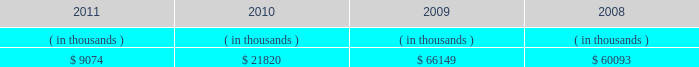Entergy new orleans , inc .
Management 2019s financial discussion and analysis also in addition to the contractual obligations , entergy new orleans has $ 53.7 million of unrecognized tax benefits and interest net of unused tax attributes and payments for which the timing of payments beyond 12 months cannot be reasonably estimated due to uncertainties in the timing of effective settlement of tax positions .
See note 3 to the financial statements for additional information regarding unrecognized tax benefits .
The planned capital investment estimate for entergy new orleans reflects capital required to support existing business .
The estimated capital expenditures are subject to periodic review and modification and may vary based on the ongoing effects of regulatory constraints , environmental compliance , market volatility , economic trends , changes in project plans , and the ability to access capital .
Management provides more information on long-term debt and preferred stock maturities in notes 5 and 6 and to the financial statements .
As an indirect , wholly-owned subsidiary of entergy corporation , entergy new orleans pays dividends from its earnings at a percentage determined monthly .
Entergy new orleans 2019s long-term debt indentures contain restrictions on the payment of cash dividends or other distributions on its common and preferred stock .
Sources of capital entergy new orleans 2019s sources to meet its capital requirements include : internally generated funds ; cash on hand ; and debt and preferred stock issuances .
Entergy new orleans may refinance , redeem , or otherwise retire debt and preferred stock prior to maturity , to the extent market conditions and interest and dividend rates are favorable .
Entergy new orleans 2019s receivables from the money pool were as follows as of december 31 for each of the following years: .
See note 4 to the financial statements for a description of the money pool .
Entergy new orleans has obtained short-term borrowing authorization from the ferc under which it may borrow through october 2013 , up to the aggregate amount , at any one time outstanding , of $ 100 million .
See note 4 to the financial statements for further discussion of entergy new orleans 2019s short-term borrowing limits .
The long-term securities issuances of entergy new orleans are limited to amounts authorized by the city council , and the current authorization extends through july 2012 .
Entergy louisiana 2019s ninemile point unit 6 self-build project in june 2011 , entergy louisiana filed with the lpsc an application seeking certification that the public necessity and convenience would be served by entergy louisiana 2019s construction of a combined-cycle gas turbine generating facility ( ninemile 6 ) at its existing ninemile point electric generating station .
Ninemile 6 will be a nominally-sized 550 mw unit that is estimated to cost approximately $ 721 million to construct , excluding interconnection and transmission upgrades .
Entergy gulf states louisiana joined in the application , seeking certification of its purchase under a life-of-unit power purchase agreement of up to 35% ( 35 % ) of the capacity and energy generated by ninemile 6 .
The ninemile 6 capacity and energy is proposed to be allocated 55% ( 55 % ) to entergy louisiana , 25% ( 25 % ) to entergy gulf states louisiana , and 20% ( 20 % ) to entergy new orleans .
In february 2012 the city council passed a resolution authorizing entergy new orleans to purchase 20% ( 20 % ) of the ninemile 6 energy and capacity .
If approvals are obtained from the lpsc and other permitting agencies , ninemile 6 construction is .
By what amount did the receivables from the money pool differ between 2010 and 2011? 
Computations: (9074 - 21820)
Answer: -12746.0. 